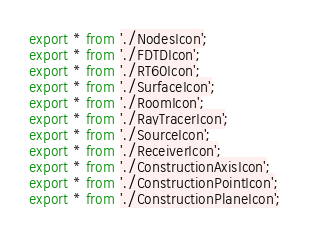<code> <loc_0><loc_0><loc_500><loc_500><_TypeScript_>export * from './NodesIcon';
export * from './FDTDIcon';
export * from './RT60Icon';
export * from './SurfaceIcon';
export * from './RoomIcon';
export * from './RayTracerIcon';
export * from './SourceIcon';
export * from './ReceiverIcon';
export * from './ConstructionAxisIcon';
export * from './ConstructionPointIcon';
export * from './ConstructionPlaneIcon';</code> 